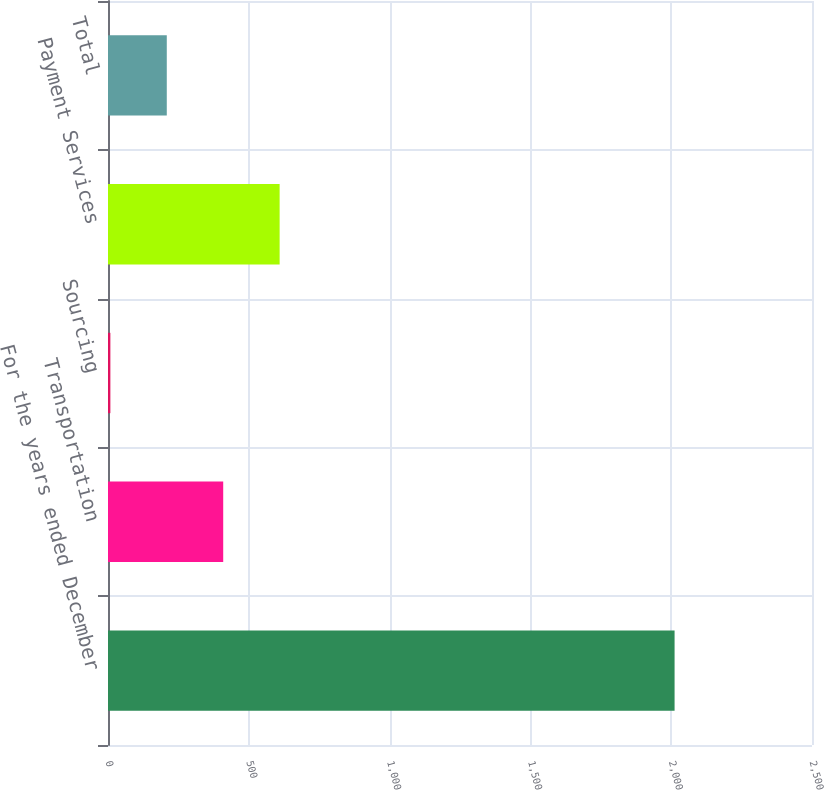Convert chart to OTSL. <chart><loc_0><loc_0><loc_500><loc_500><bar_chart><fcel>For the years ended December<fcel>Transportation<fcel>Sourcing<fcel>Payment Services<fcel>Total<nl><fcel>2012<fcel>409.12<fcel>8.4<fcel>609.48<fcel>208.76<nl></chart> 